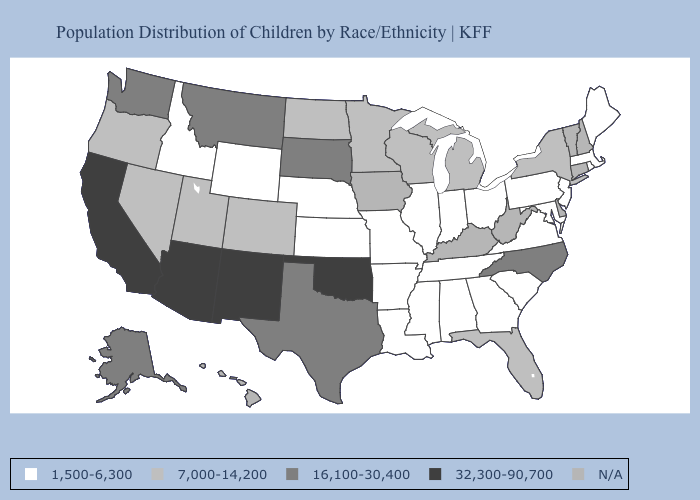Among the states that border California , which have the lowest value?
Answer briefly. Nevada, Oregon. Does New York have the highest value in the Northeast?
Concise answer only. Yes. How many symbols are there in the legend?
Keep it brief. 5. Does Missouri have the highest value in the MidWest?
Short answer required. No. What is the value of Alaska?
Concise answer only. 16,100-30,400. Is the legend a continuous bar?
Give a very brief answer. No. How many symbols are there in the legend?
Quick response, please. 5. Name the states that have a value in the range 32,300-90,700?
Write a very short answer. Arizona, California, New Mexico, Oklahoma. What is the value of West Virginia?
Short answer required. N/A. Does Oklahoma have the highest value in the South?
Write a very short answer. Yes. What is the value of Georgia?
Keep it brief. 1,500-6,300. What is the value of Louisiana?
Quick response, please. 1,500-6,300. Does Montana have the highest value in the West?
Short answer required. No. What is the lowest value in the USA?
Answer briefly. 1,500-6,300. 